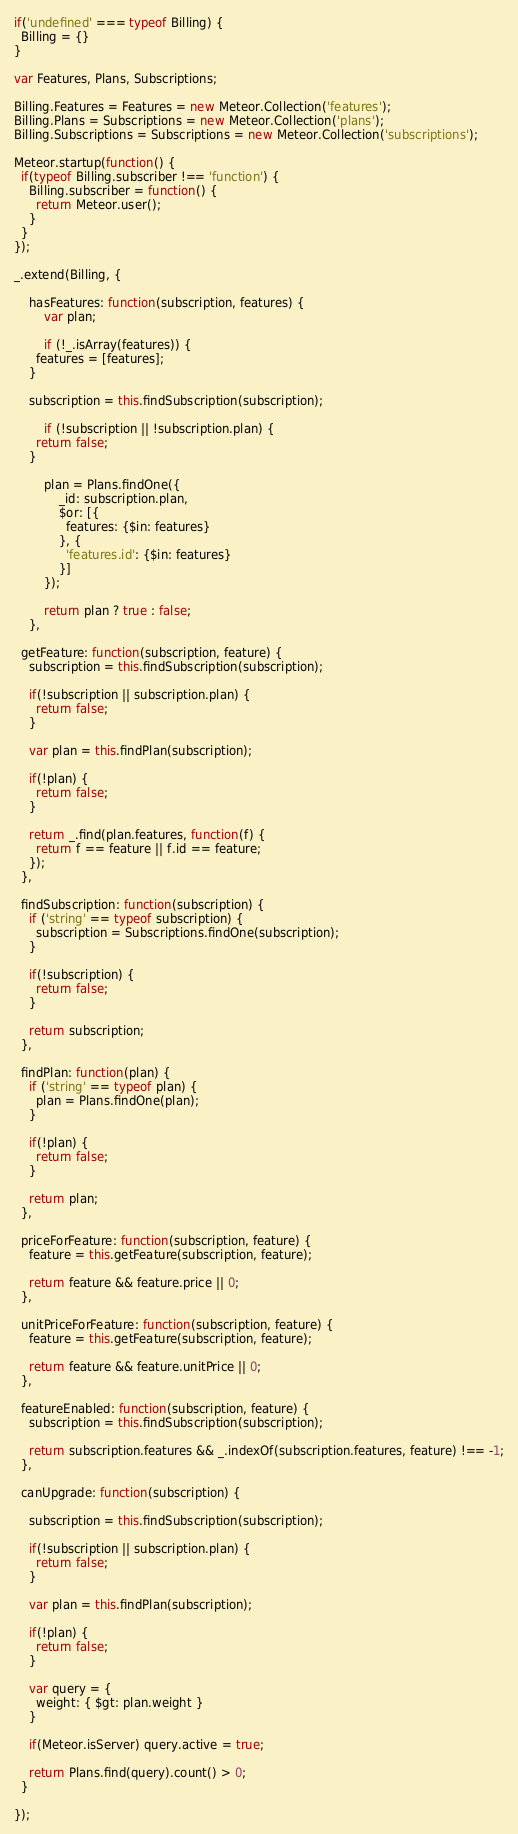<code> <loc_0><loc_0><loc_500><loc_500><_JavaScript_>if('undefined' === typeof Billing) {
  Billing = {}
}

var Features, Plans, Subscriptions;

Billing.Features = Features = new Meteor.Collection('features');
Billing.Plans = Subscriptions = new Meteor.Collection('plans');
Billing.Subscriptions = Subscriptions = new Meteor.Collection('subscriptions');

Meteor.startup(function() {
  if(typeof Billing.subscriber !== 'function') {
    Billing.subscriber = function() {
      return Meteor.user();
    }
  }
});

_.extend(Billing, {
  
	hasFeatures: function(subscription, features) {
		var plan;
		
		if (!_.isArray(features)) {
      features = [features];
    }

    subscription = this.findSubscription(subscription);
		
		if (!subscription || !subscription.plan) {
      return false;
    }
		
		plan = Plans.findOne({
			_id: subscription.plan,
			$or: [{
			  features: {$in: features}
			}, {
			  'features.id': {$in: features}
			}]
		});
		
		return plan ? true : false;
	},
  
  getFeature: function(subscription, feature) {    
    subscription = this.findSubscription(subscription);
    
    if(!subscription || subscription.plan) {
      return false;
    }
    
    var plan = this.findPlan(subscription);
    
    if(!plan) {
      return false;
    }
    
    return _.find(plan.features, function(f) {
      return f == feature || f.id == feature;
    });
  },
  
  findSubscription: function(subscription) {
    if ('string' == typeof subscription) {
      subscription = Subscriptions.findOne(subscription);
    }
    
    if(!subscription) {
      return false;
    }
    
    return subscription;
  },
  
  findPlan: function(plan) {
    if ('string' == typeof plan) {
      plan = Plans.findOne(plan);
    }
    
    if(!plan) {
      return false;
    }
    
    return plan;
  },
  
  priceForFeature: function(subscription, feature) {
    feature = this.getFeature(subscription, feature);

    return feature && feature.price || 0;
  },
  
  unitPriceForFeature: function(subscription, feature) {
    feature = this.getFeature(subscription, feature);

    return feature && feature.unitPrice || 0;
  },
  
  featureEnabled: function(subscription, feature) { 
    subscription = this.findSubscription(subscription);
    
    return subscription.features && _.indexOf(subscription.features, feature) !== -1;
  },
  
  canUpgrade: function(subscription) {
    
    subscription = this.findSubscription(subscription);
    
    if(!subscription || subscription.plan) {
      return false;
    }
    
    var plan = this.findPlan(subscription);
    
    if(!plan) {
      return false;
    }
    
    var query = {
      weight: { $gt: plan.weight }
    }
    
    if(Meteor.isServer) query.active = true;

    return Plans.find(query).count() > 0;
  }
  
});</code> 